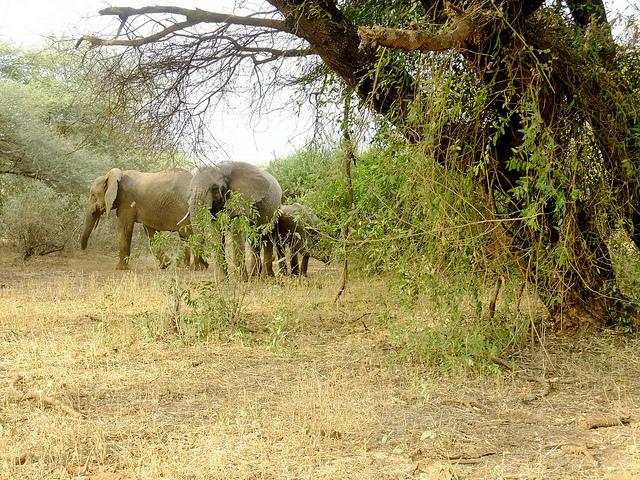How many elephants are huddled together on the left side of the hanging tree? Please explain your reasoning. three. Two adults and one baby elephant stand together on a treeline path. 